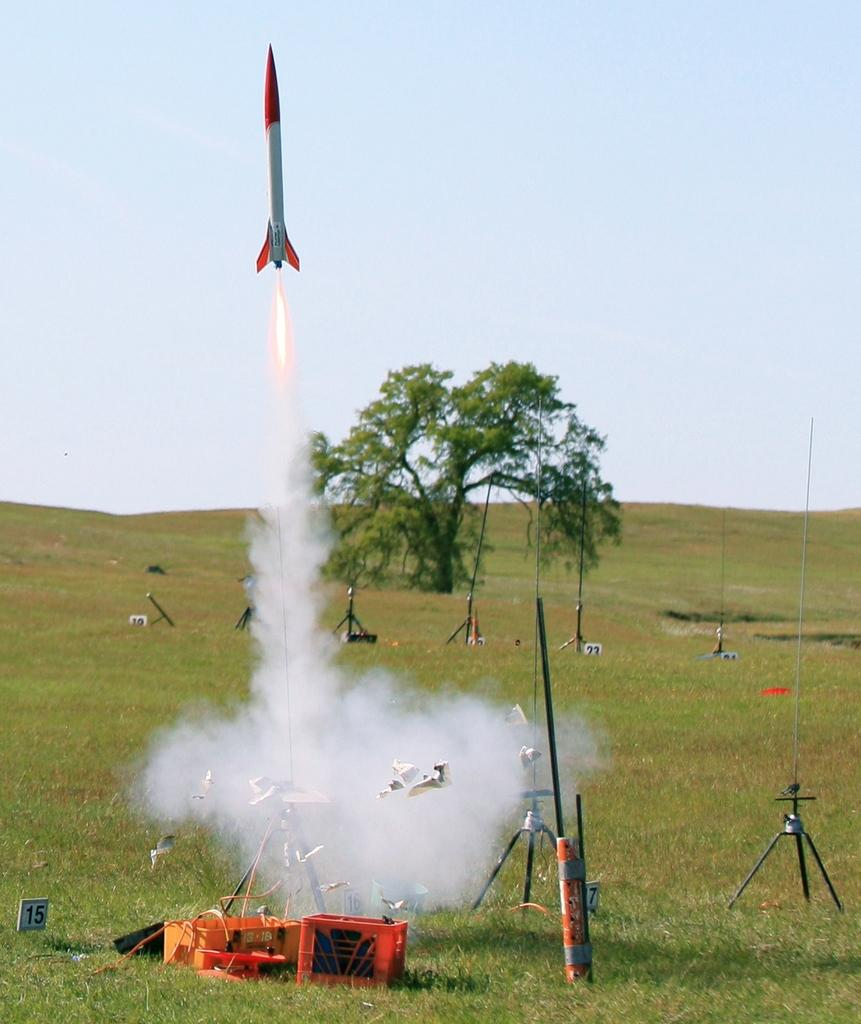What type of natural element can be seen in the image? There is a tree in the image. What structures are present in the image? There are stands in the image. What else can be seen in the image besides the tree and stands? There are objects in the image. What is visible in the background of the image? There is a rocket and the sky visible in the background of the image. Where is the shelf located in the image? There is no shelf present in the image. What type of sport is being played in the image? There is no sport or baseball present in the image. 